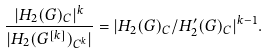Convert formula to latex. <formula><loc_0><loc_0><loc_500><loc_500>\frac { | H _ { 2 } ( G ) _ { C } | ^ { k } } { | H _ { 2 } ( G ^ { [ k ] } ) _ { C ^ { k } } | } = | H _ { 2 } ( G ) _ { C } / H _ { 2 } ^ { \prime } ( G ) _ { C } | ^ { k - 1 } .</formula> 